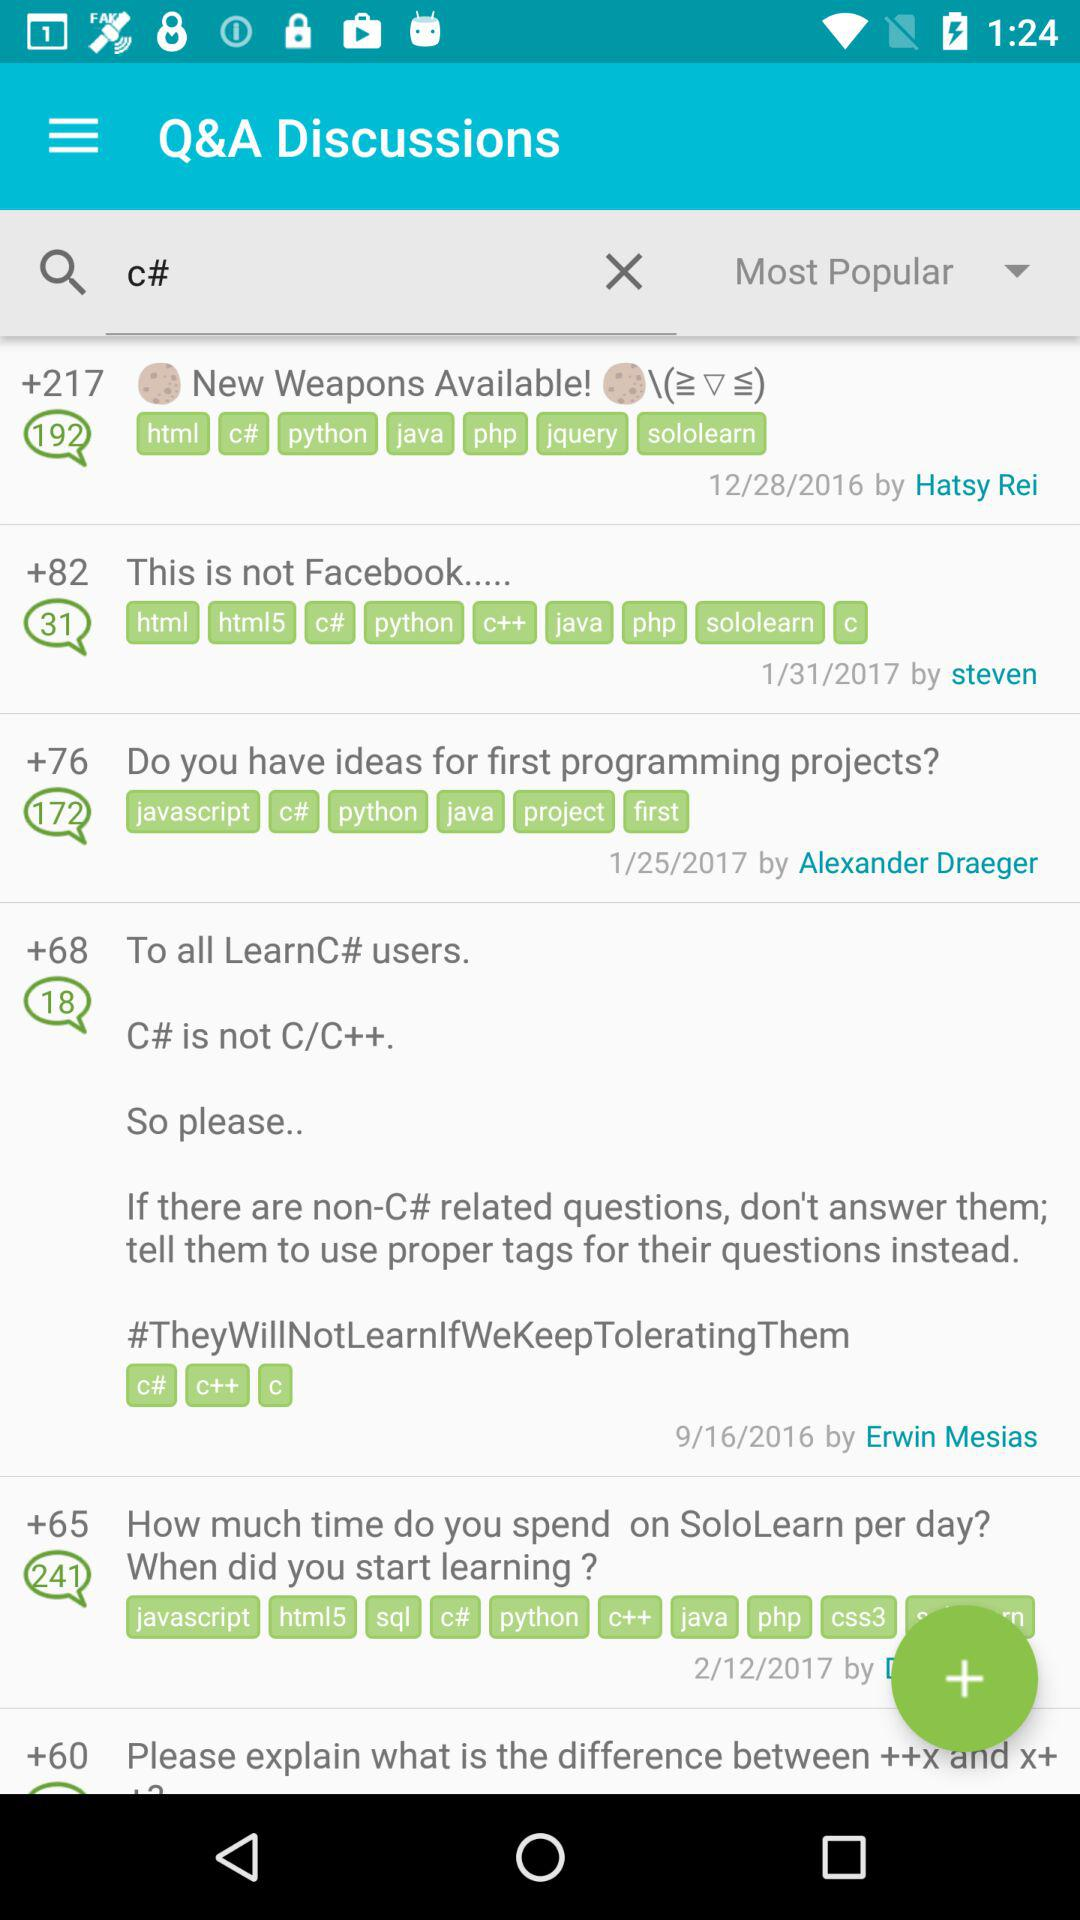What is the date of question "New weapons available"? The date of the question "New weapons available" is 12/28/2016. 